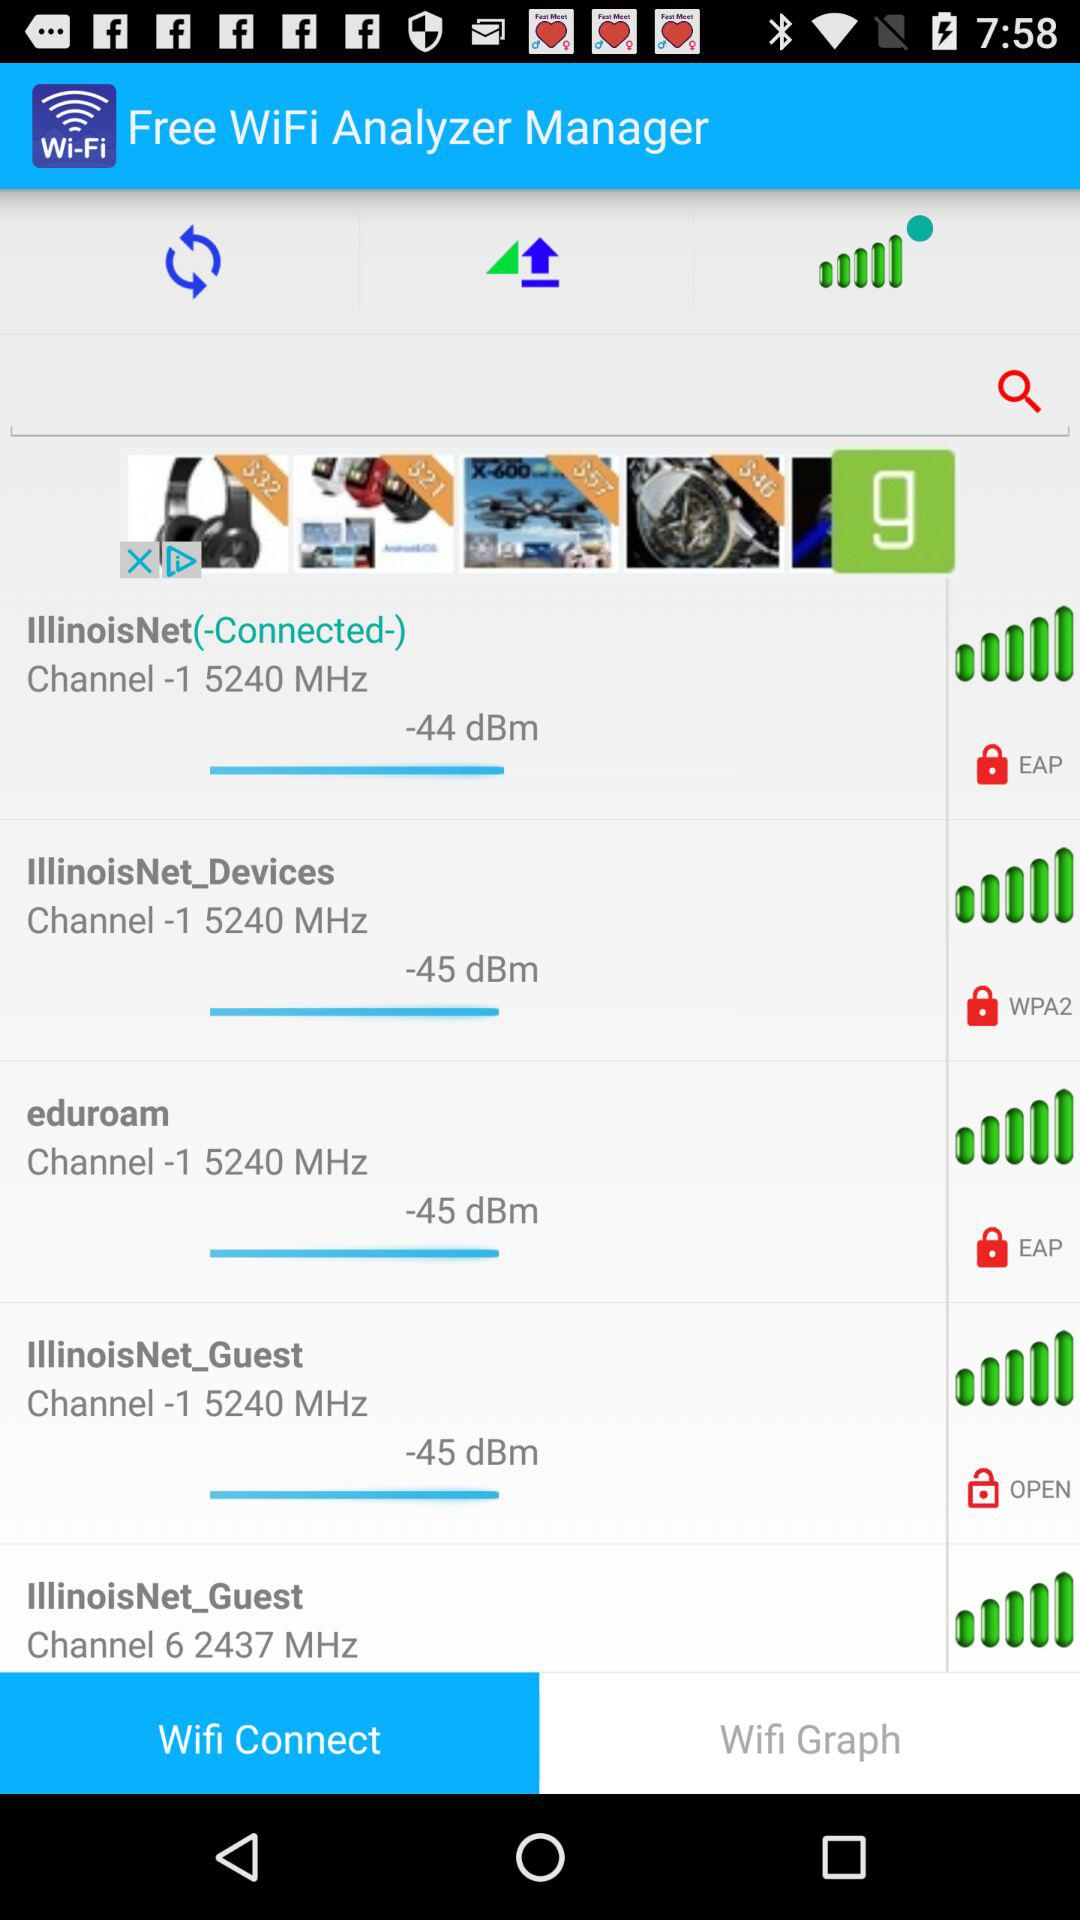What is the dBm value of "eduroam"? The dBm value of "eduroam" is -45. 